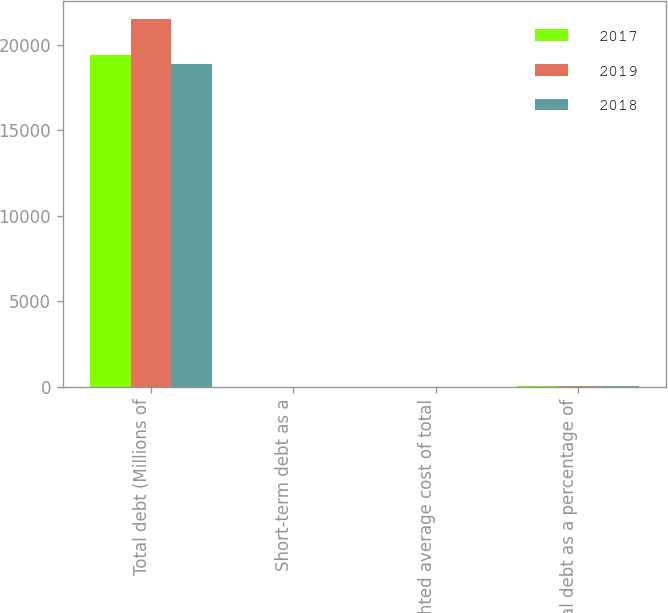Convert chart. <chart><loc_0><loc_0><loc_500><loc_500><stacked_bar_chart><ecel><fcel>Total debt (Millions of<fcel>Short-term debt as a<fcel>Weighted average cost of total<fcel>Total debt as a percentage of<nl><fcel>2017<fcel>19390<fcel>6.8<fcel>2.9<fcel>45.6<nl><fcel>2019<fcel>21496<fcel>12.1<fcel>3.2<fcel>47.8<nl><fcel>2018<fcel>18870<fcel>1.1<fcel>3.3<fcel>57.5<nl></chart> 